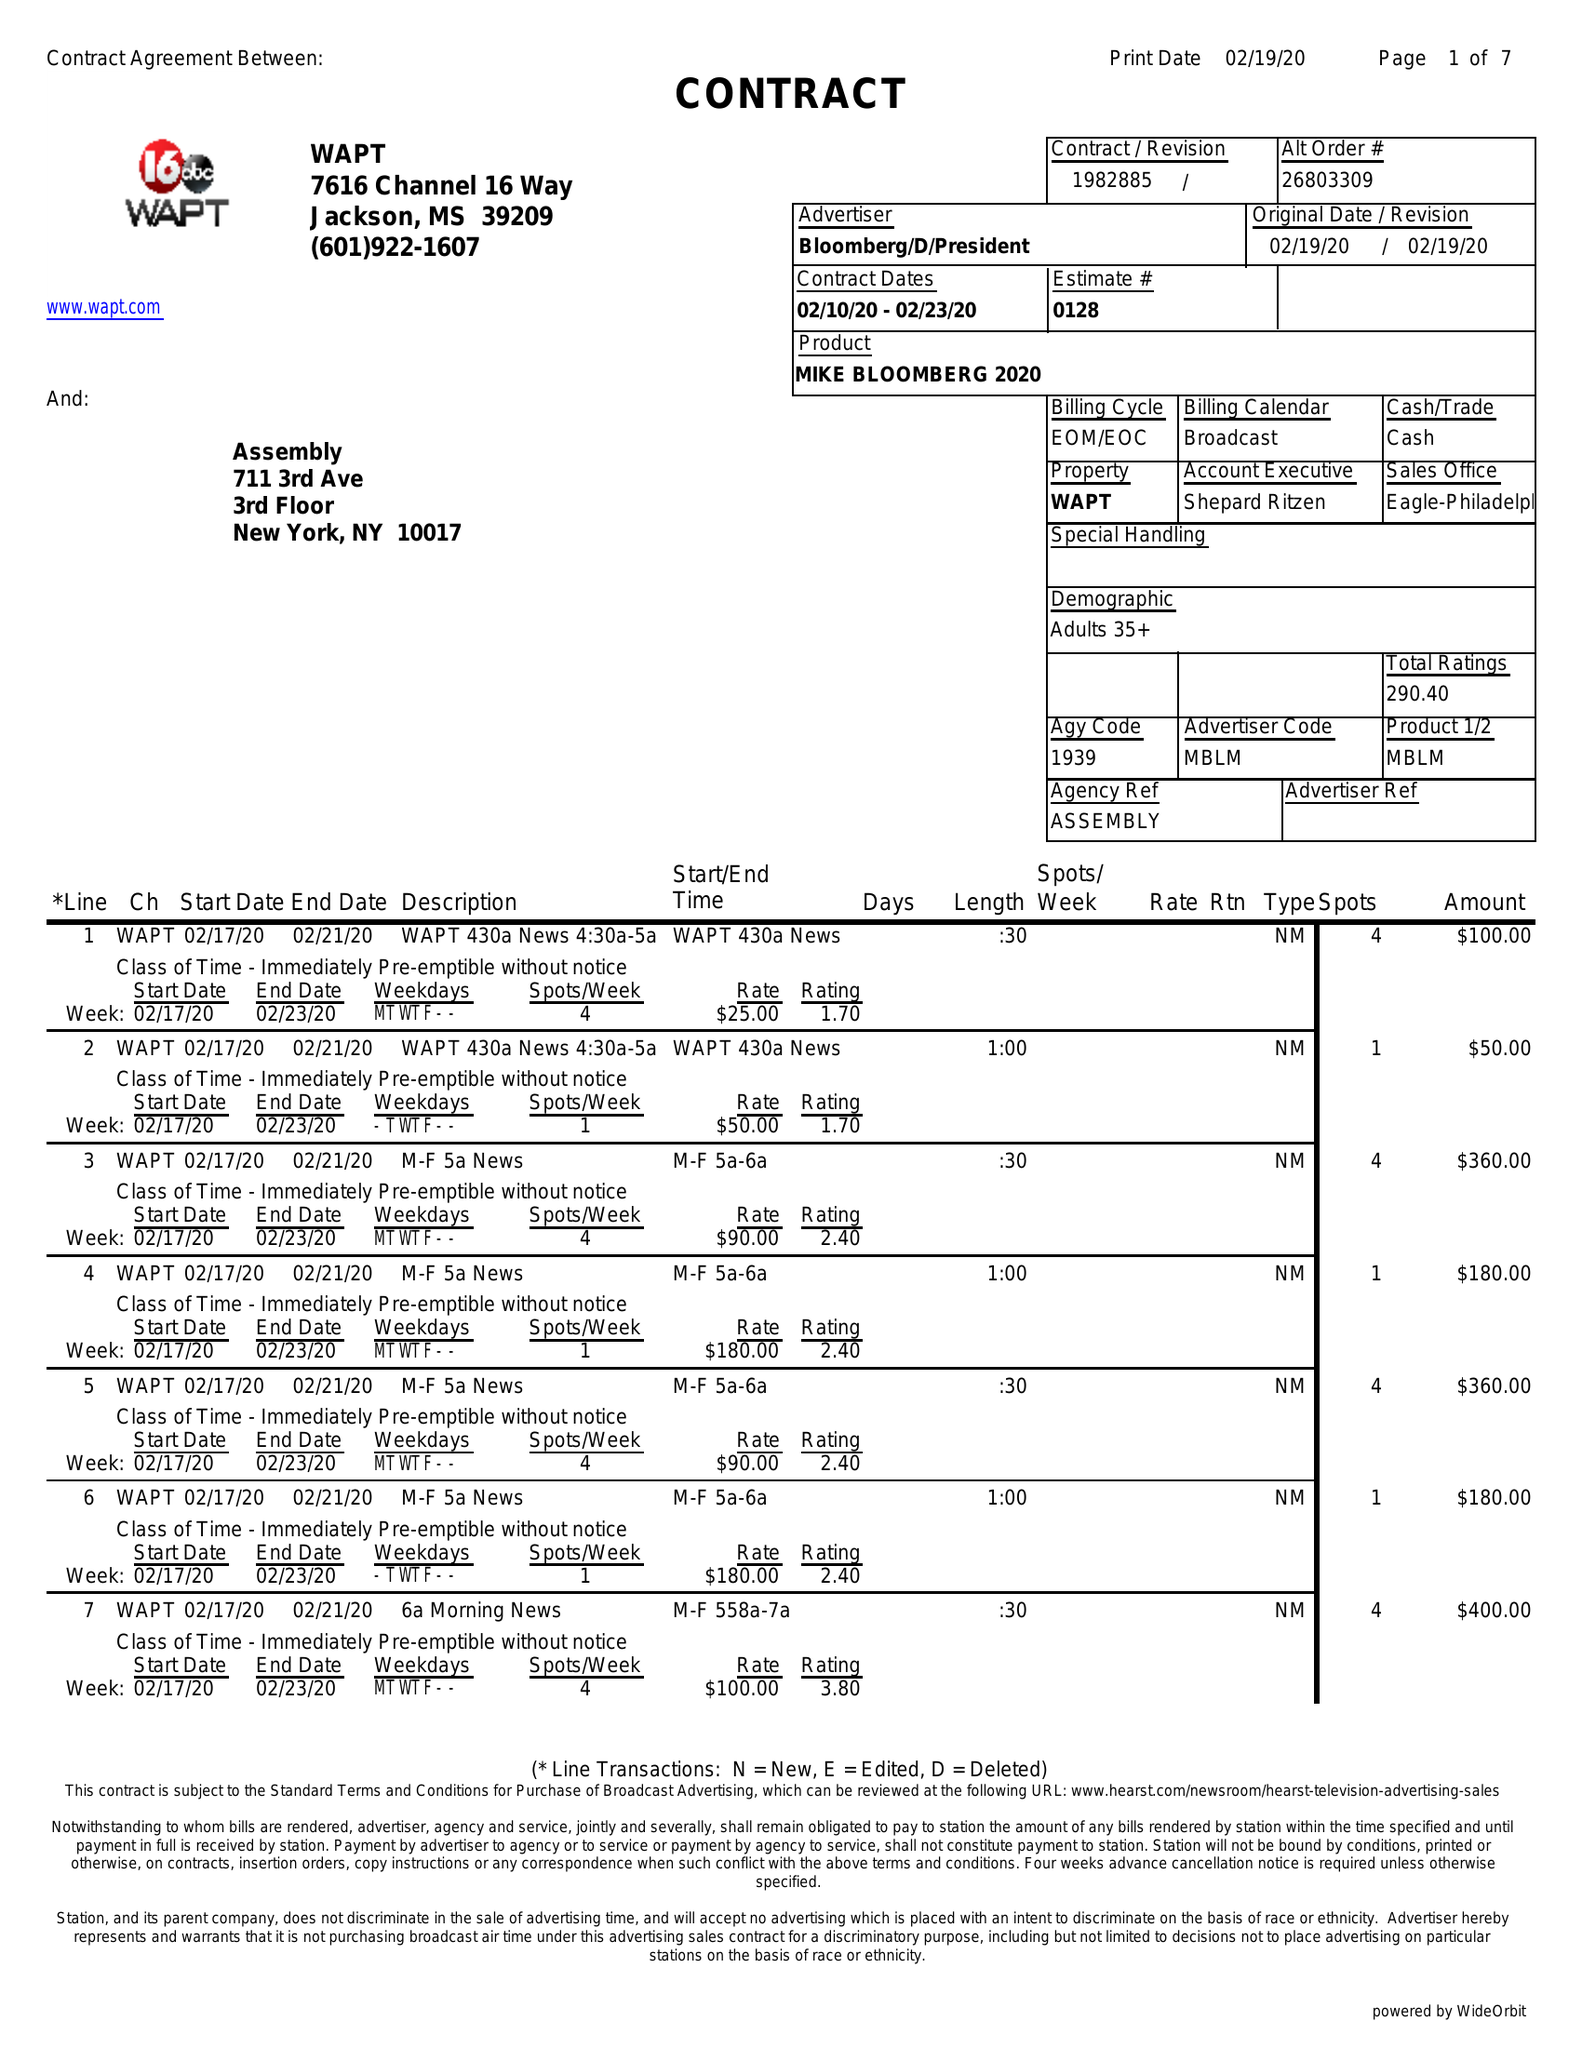What is the value for the flight_to?
Answer the question using a single word or phrase. 02/23/20 